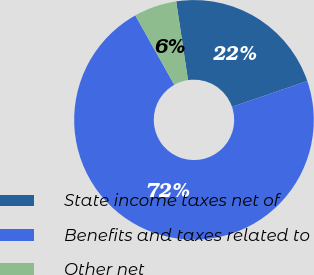<chart> <loc_0><loc_0><loc_500><loc_500><pie_chart><fcel>State income taxes net of<fcel>Benefits and taxes related to<fcel>Other net<nl><fcel>22.12%<fcel>72.12%<fcel>5.77%<nl></chart> 